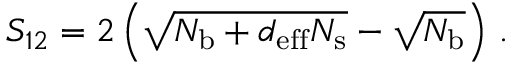<formula> <loc_0><loc_0><loc_500><loc_500>S _ { 1 2 } = 2 \left ( \sqrt { N _ { b } + d _ { e f f } N _ { s } } - \sqrt { N _ { b } } \right ) \, .</formula> 